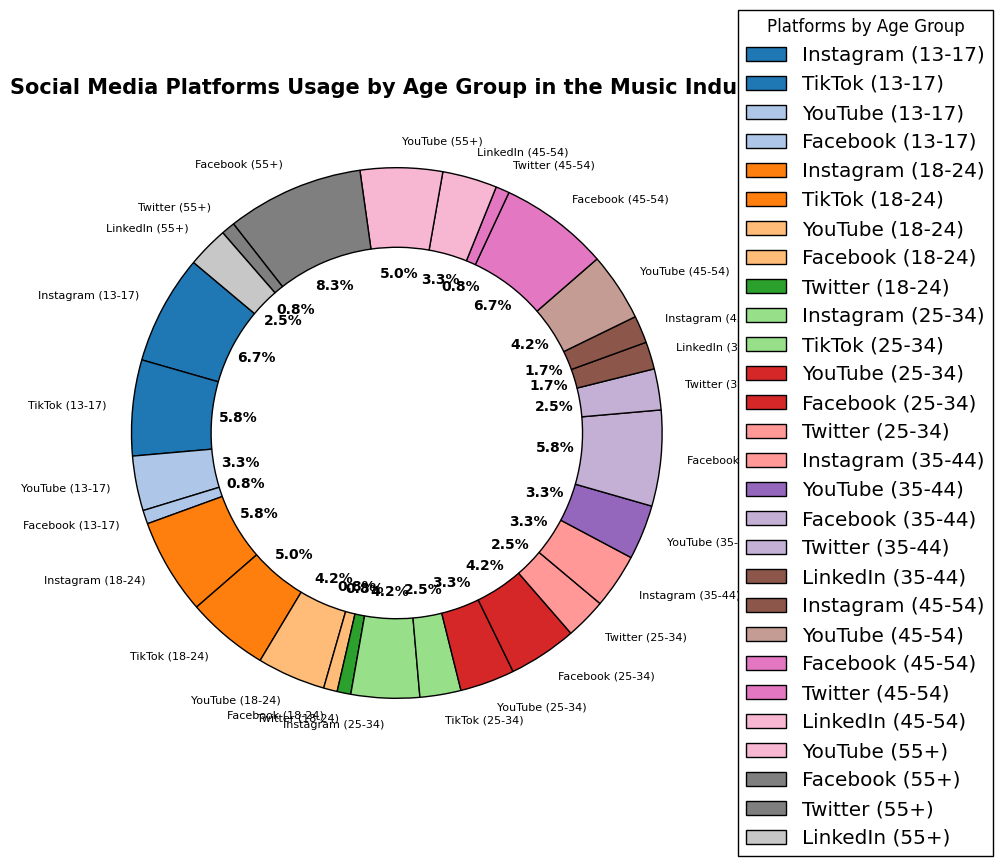What age group has the highest usage percentage of Instagram? Look at the sections labeled "Instagram" and find the one with the largest percentage. The 13-17 age group uses Instagram the most at 40%.
Answer: 13-17 Which platform is the least used by the 45-54 age group? For the 45-54 age group, identify the segment with the smallest percentage. Twitter is the least used at 5%.
Answer: Twitter Compare the usage percentage of Facebook between the 25-34 and 55+ age groups. Which one is higher? Look at the sections for Facebook. The 55+ group uses Facebook at 50%, while the 25-34 group uses it at 25%. Hence, the 55+ group has a higher usage percentage.
Answer: 55+ What's the total usage percentage for Instagram across all age groups? Sum the percentages for Instagram across all age groups: 40 (13-17) + 35 (18-24) + 25 (25-34) + 20 (35-44) + 10 (45-54) = 130.
Answer: 130 Which platform has an equal usage percentage in two or more age groups? Find platforms used equally in different age groups. Facebook is used equally by the 18-24 and 25-34 age groups, both at 5%.
Answer: Facebook What is the largest visual segment in the plot? Identify the segment with the largest wedge size or percentage. The 55+ age group for Facebook at 50% is the largest.
Answer: 55+ Facebook Is TikTok more popular than Twitter across all age groups? Sum TikTok percentages: 35 (13-17) + 30 (18-24) + 15 (25-34) = 80. Sum Twitter: 5 (18-24) + 15 (25-34) + 15 (35-44) + 5 (45-54) = 40. TikTok's total is higher.
Answer: Yes Which platform is equally popular among the 13-17 and 18-24 age groups? Compare the percentages for each platform in both age groups. Instagram has almost similar high values (13-17: 40%, 18-24: 35%).
Answer: Instagram Which age group shows a balanced use of multiple platforms rather than one dominant platform? Check which age group has close percentages across multiple platforms. The 25-34 age group has a balanced use: Instagram (25%), Facebook (25%), YouTube (20%), Twitter (15%), and TikTok (15%).
Answer: 25-34 How does the usage of LinkedIn change from the 35-44 age group to the 55+ age group? Look at the sections for LinkedIn: 35-44 group = 10%, 45-54 group = 20%, 55+ group = 15%.
Answer: Increases from 10% to 20%, then decreases to 15% 